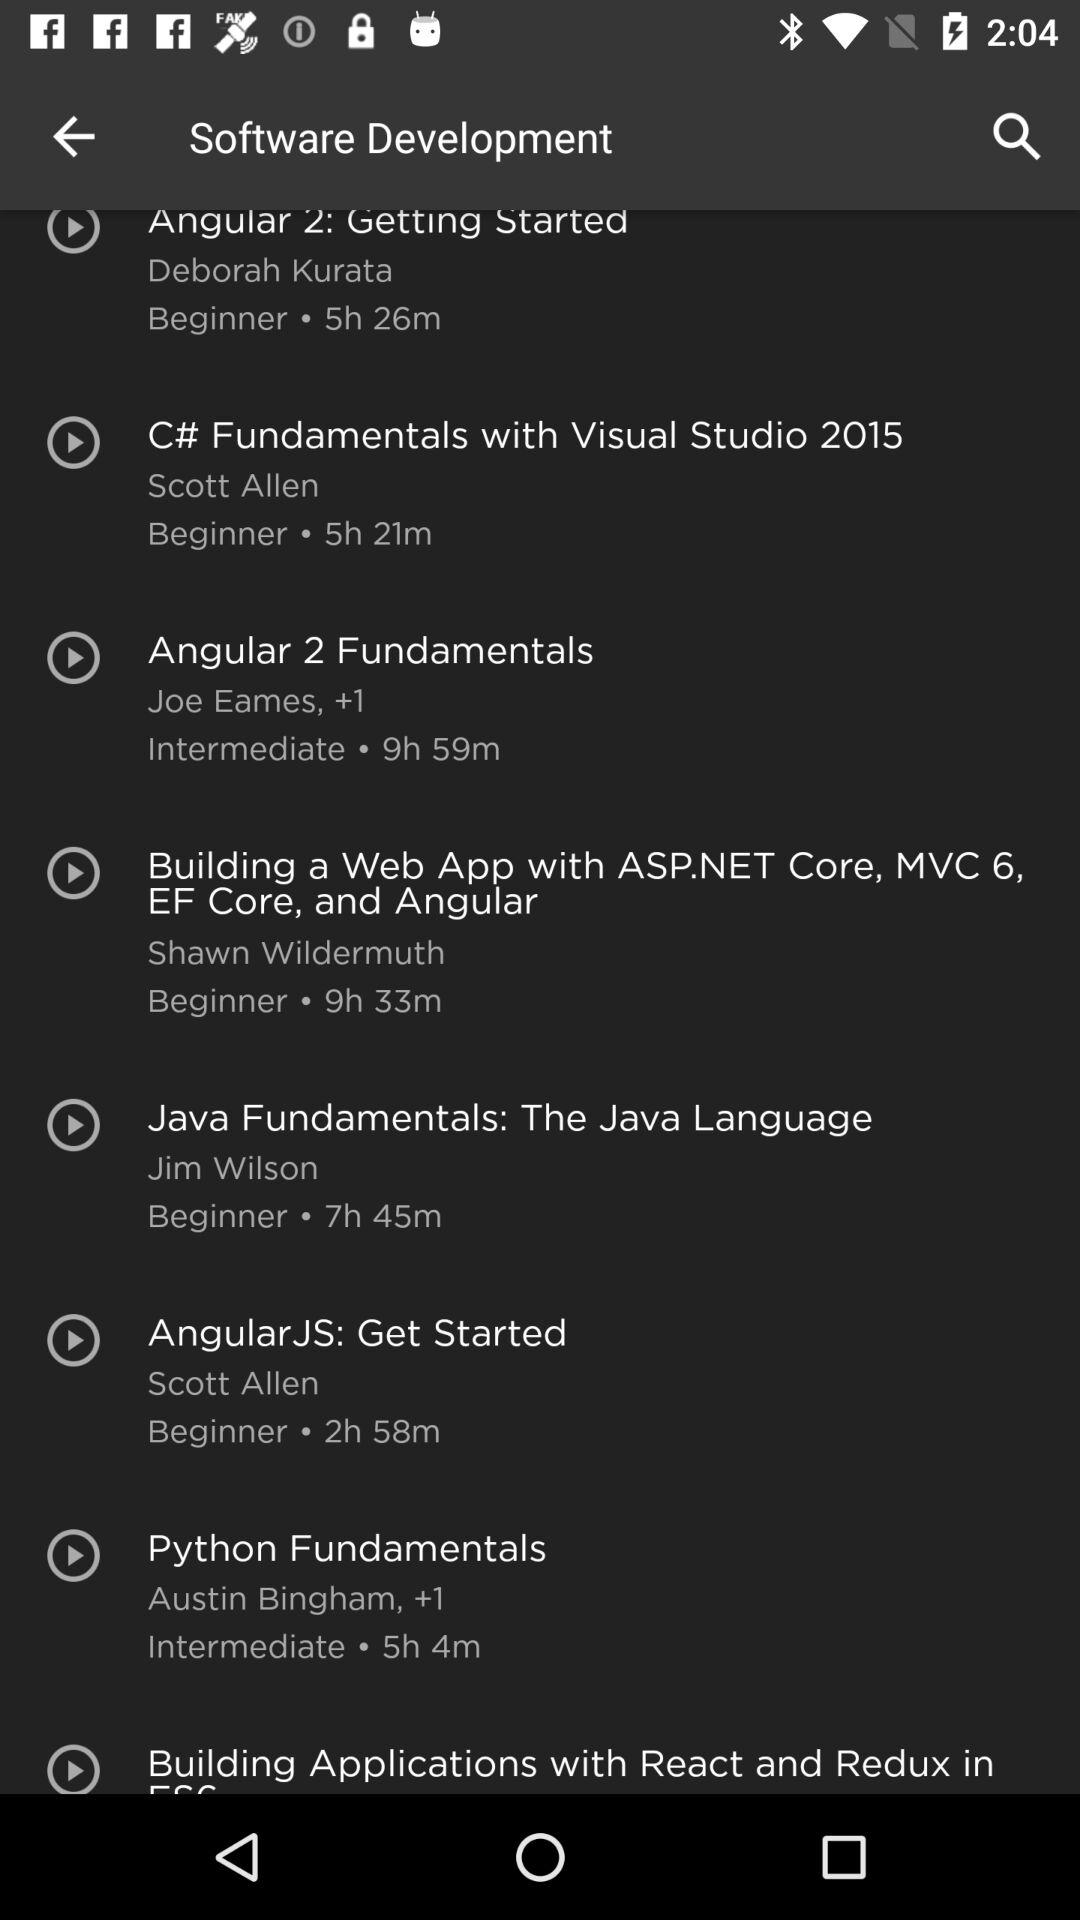What is the duration of the "Angular 2 Fundamentals" course? The 'Angular 2 Fundamentals' course, instructed by Joe Eames and an additional contributor, is designed for intermediate learners and spans a total of 9 hours and 59 minutes, according to the details in the image. 